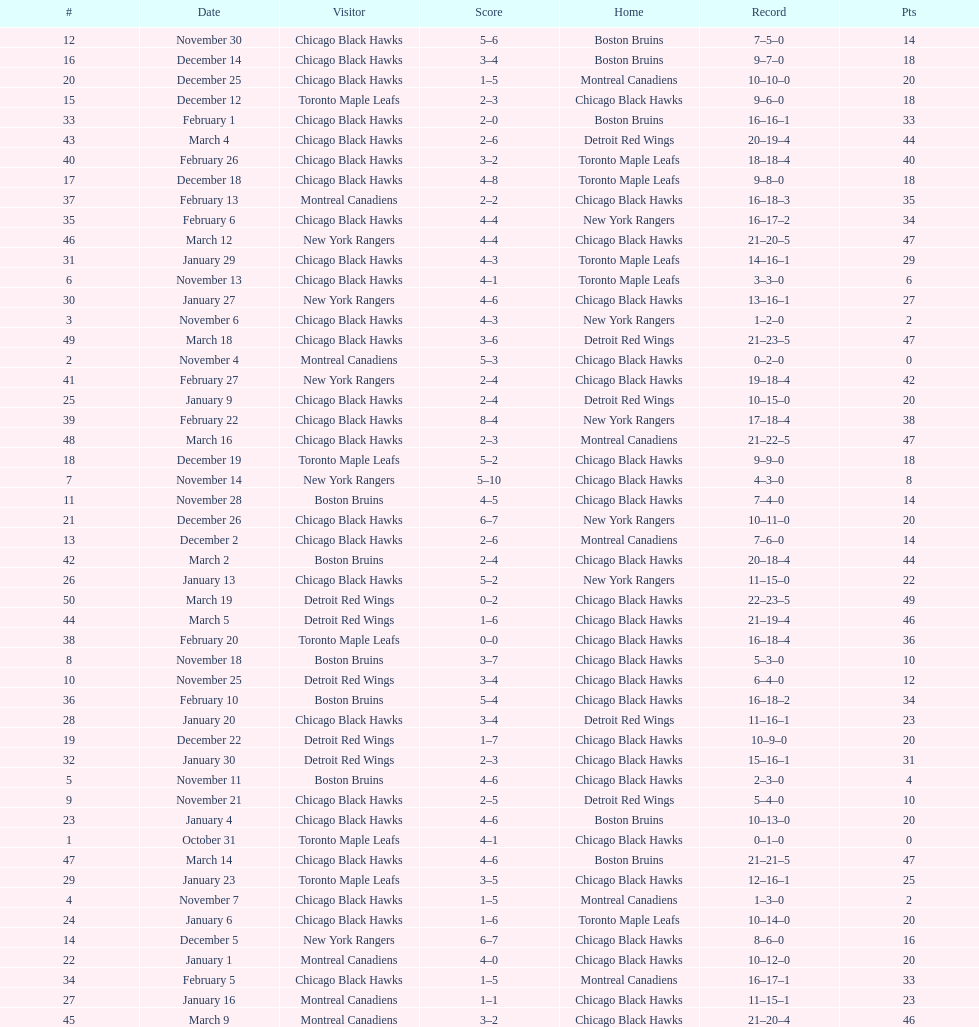Who was the next team that the boston bruins played after november 11? Chicago Black Hawks. 